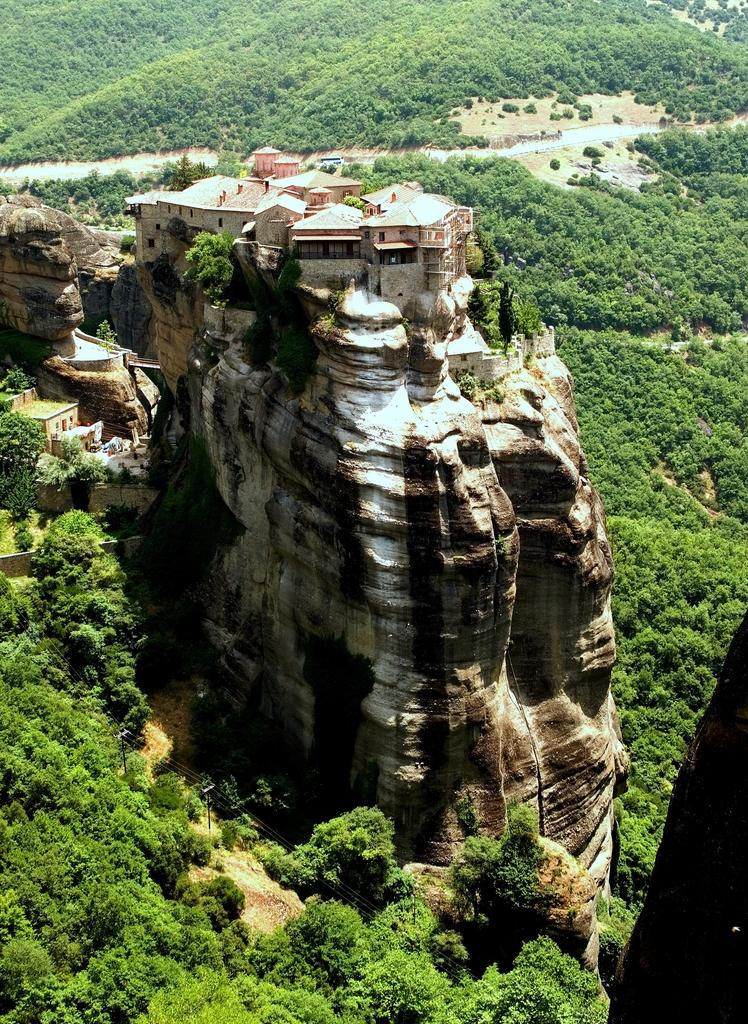What type of structures can be seen on the mountain in the image? There are buildings on the mountain in the image. What natural elements are visible in the image? There are many trees visible in the image. What type of ring can be seen on the corn in the image? There is no corn or ring present in the image. What riddle is depicted in the image? There is no riddle depicted in the image; it features buildings on a mountain and trees. 